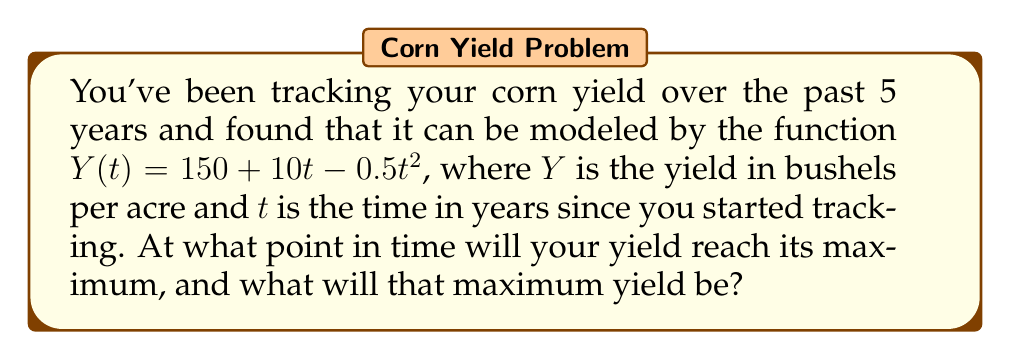Provide a solution to this math problem. To solve this problem, we'll use calculus to find the maximum of the given function.

1) First, we need to find the derivative of $Y(t)$:
   $$\frac{dY}{dt} = 10 - t$$

2) To find the maximum, we set the derivative equal to zero and solve for $t$:
   $$10 - t = 0$$
   $$t = 10$$

3) This critical point ($t = 10$) gives us the time at which the yield is maximized.

4) To confirm it's a maximum (not a minimum), we can check the second derivative:
   $$\frac{d^2Y}{dt^2} = -1$$
   Since this is negative, we confirm that $t = 10$ gives a maximum.

5) To find the maximum yield, we plug $t = 10$ into our original function:
   $$Y(10) = 150 + 10(10) - 0.5(10)^2$$
   $$Y(10) = 150 + 100 - 50 = 200$$

Therefore, the yield will reach its maximum after 10 years, and the maximum yield will be 200 bushels per acre.
Answer: Maximum at $t = 10$ years, $Y(10) = 200$ bushels/acre 